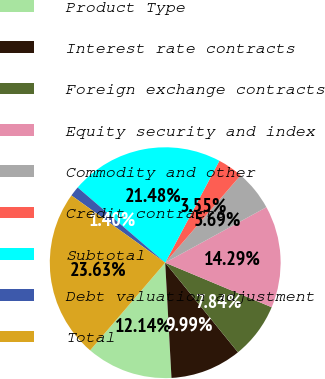Convert chart. <chart><loc_0><loc_0><loc_500><loc_500><pie_chart><fcel>Product Type<fcel>Interest rate contracts<fcel>Foreign exchange contracts<fcel>Equity security and index<fcel>Commodity and other<fcel>Credit contracts<fcel>Subtotal<fcel>Debt valuation adjustment<fcel>Total<nl><fcel>12.14%<fcel>9.99%<fcel>7.84%<fcel>14.29%<fcel>5.69%<fcel>3.55%<fcel>21.48%<fcel>1.4%<fcel>23.63%<nl></chart> 